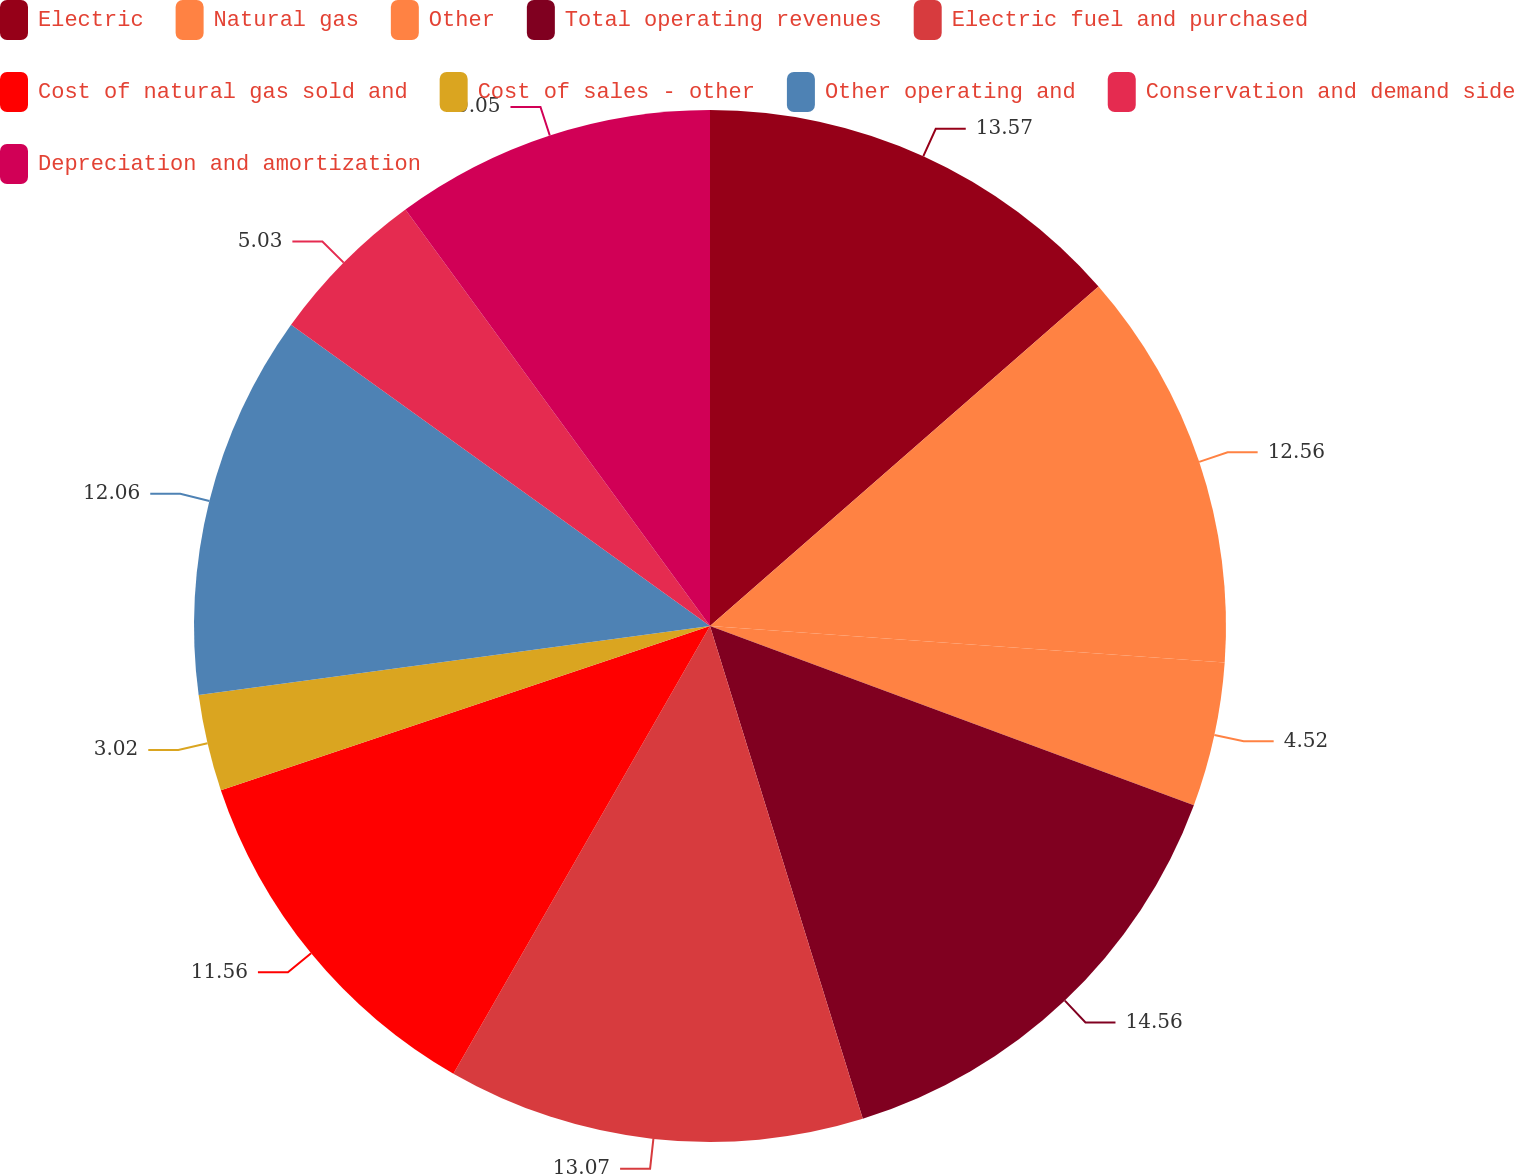Convert chart to OTSL. <chart><loc_0><loc_0><loc_500><loc_500><pie_chart><fcel>Electric<fcel>Natural gas<fcel>Other<fcel>Total operating revenues<fcel>Electric fuel and purchased<fcel>Cost of natural gas sold and<fcel>Cost of sales - other<fcel>Other operating and<fcel>Conservation and demand side<fcel>Depreciation and amortization<nl><fcel>13.57%<fcel>12.56%<fcel>4.52%<fcel>14.57%<fcel>13.07%<fcel>11.56%<fcel>3.02%<fcel>12.06%<fcel>5.03%<fcel>10.05%<nl></chart> 